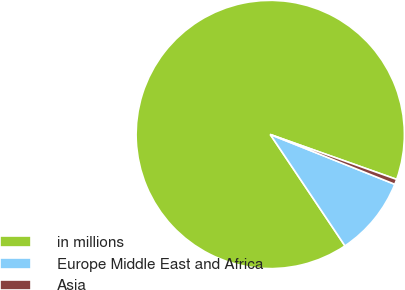Convert chart to OTSL. <chart><loc_0><loc_0><loc_500><loc_500><pie_chart><fcel>in millions<fcel>Europe Middle East and Africa<fcel>Asia<nl><fcel>89.83%<fcel>9.54%<fcel>0.62%<nl></chart> 